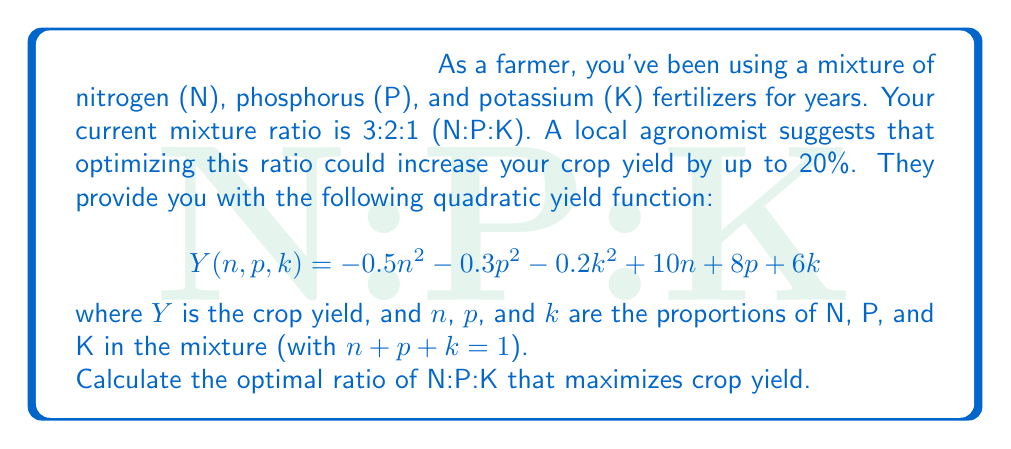Could you help me with this problem? To find the optimal ratio, we need to maximize the yield function $Y(n,p,k)$ subject to the constraint $n + p + k = 1$. We can use the method of Lagrange multipliers:

1) Form the Lagrangian function:
   $$L(n,p,k,\lambda) = -0.5n^2 - 0.3p^2 - 0.2k^2 + 10n + 8p + 6k + \lambda(1-n-p-k)$$

2) Take partial derivatives and set them to zero:
   $$\frac{\partial L}{\partial n} = -n + 10 - \lambda = 0$$
   $$\frac{\partial L}{\partial p} = -0.6p + 8 - \lambda = 0$$
   $$\frac{\partial L}{\partial k} = -0.4k + 6 - \lambda = 0$$
   $$\frac{\partial L}{\partial \lambda} = 1-n-p-k = 0$$

3) From these equations:
   $$n = 10 - \lambda$$
   $$p = \frac{8 - \lambda}{0.6} = \frac{40 - 5\lambda}{3}$$
   $$k = \frac{6 - \lambda}{0.4} = 15 - 2.5\lambda$$

4) Substitute these into the constraint equation:
   $$(10 - \lambda) + (\frac{40 - 5\lambda}{3}) + (15 - 2.5\lambda) = 1$$

5) Solve for $\lambda$:
   $$10 - \lambda + \frac{40 - 5\lambda}{3} + 15 - 2.5\lambda = 1$$
   $$30 - 3\lambda + 40 - 5\lambda + 45 - 7.5\lambda = 3$$
   $$115 - 15.5\lambda = 3$$
   $$112 = 15.5\lambda$$
   $$\lambda = \frac{112}{15.5} \approx 7.23$$

6) Substitute this value back to find $n$, $p$, and $k$:
   $$n = 10 - 7.23 = 2.77$$
   $$p = \frac{40 - 5(7.23)}{3} = 2.38$$
   $$k = 15 - 2.5(7.23) = 0.85$$

7) Normalize these values to get the ratio:
   $$N:P:K = 2.77 : 2.38 : 0.85 \approx 3.26 : 2.80 : 1$$
Answer: 3.26 : 2.80 : 1 